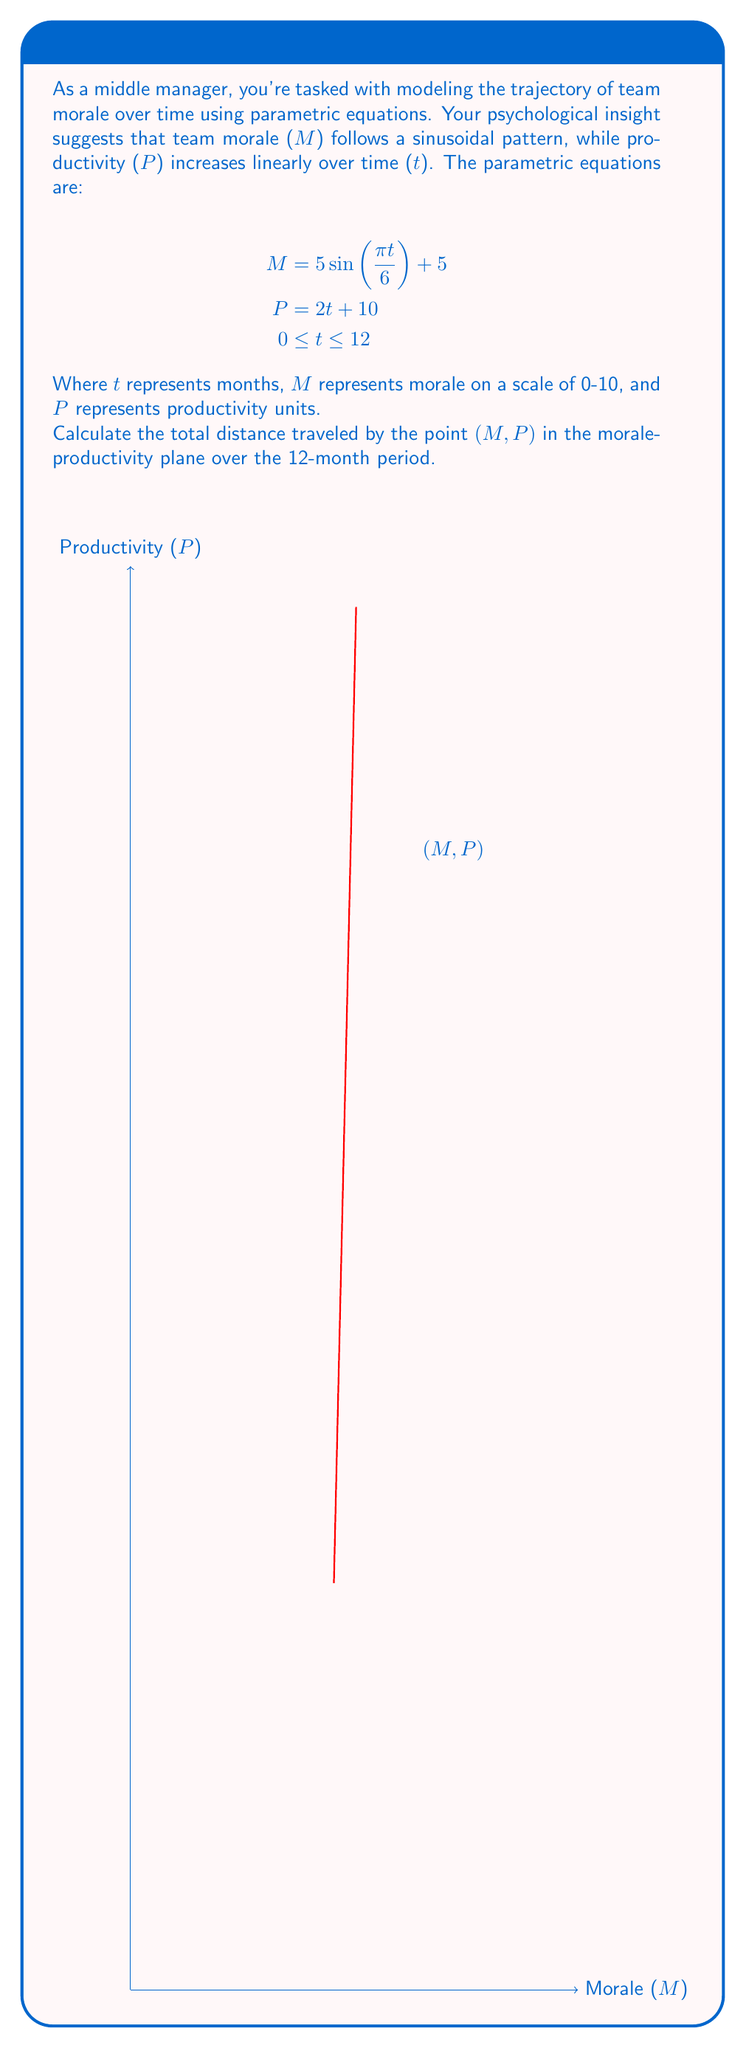What is the answer to this math problem? To solve this problem, we'll follow these steps:

1) The distance traveled by a point $(x(t), y(t))$ over an interval $[a,b]$ is given by the arc length formula:

   $$L = \int_a^b \sqrt{(\frac{dx}{dt})^2 + (\frac{dy}{dt})^2} dt$$

2) In our case, $x(t) = M = 5 \sin(\frac{\pi t}{6}) + 5$ and $y(t) = P = 2t + 10$

3) We need to find $\frac{dM}{dt}$ and $\frac{dP}{dt}$:

   $$\frac{dM}{dt} = 5 \cdot \frac{\pi}{6} \cos(\frac{\pi t}{6}) = \frac{5\pi}{6} \cos(\frac{\pi t}{6})$$
   $$\frac{dP}{dt} = 2$$

4) Substituting into the arc length formula:

   $$L = \int_0^{12} \sqrt{(\frac{5\pi}{6} \cos(\frac{\pi t}{6}))^2 + 2^2} dt$$

5) Simplify under the square root:

   $$L = \int_0^{12} \sqrt{\frac{25\pi^2}{36} \cos^2(\frac{\pi t}{6}) + 4} dt$$

6) This integral doesn't have an elementary antiderivative, so we need to use numerical integration methods to approximate the result.

7) Using a numerical integration tool or calculator, we find:

   $$L \approx 33.75$$

Thus, the total distance traveled by the point $(M, P)$ over the 12-month period is approximately 33.75 units in the morale-productivity plane.
Answer: 33.75 units 